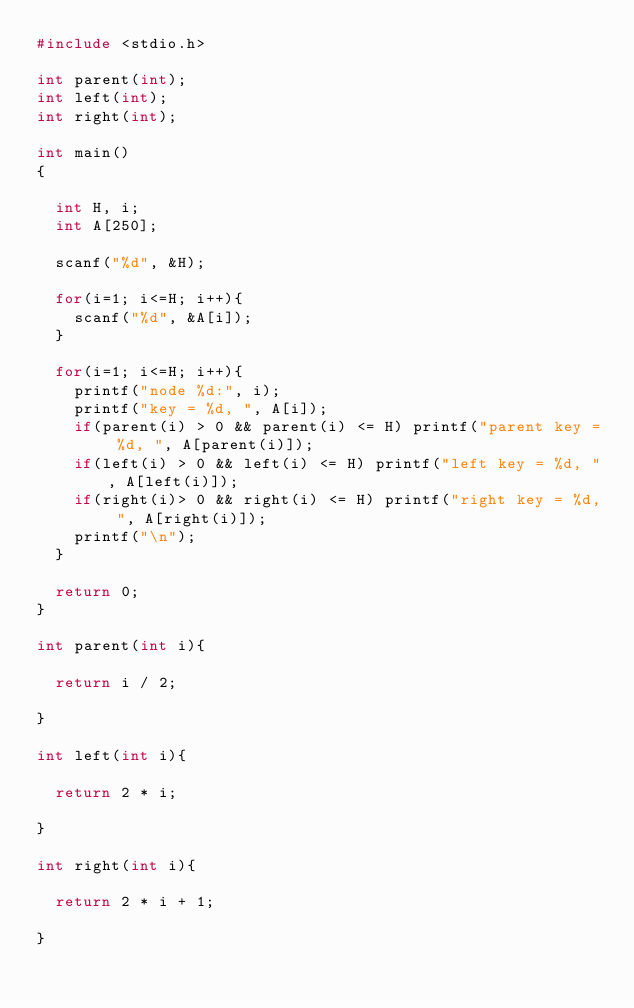<code> <loc_0><loc_0><loc_500><loc_500><_C_>#include <stdio.h>

int parent(int);
int left(int);
int right(int);

int main()
{

  int H, i;
  int A[250];

  scanf("%d", &H);

  for(i=1; i<=H; i++){
    scanf("%d", &A[i]);
  }

  for(i=1; i<=H; i++){
    printf("node %d:", i);
    printf("key = %d, ", A[i]);
    if(parent(i) > 0 && parent(i) <= H) printf("parent key = %d, ", A[parent(i)]);
    if(left(i) > 0 && left(i) <= H) printf("left key = %d, ", A[left(i)]);
    if(right(i)> 0 && right(i) <= H) printf("right key = %d, ", A[right(i)]);
    printf("\n");
  }

  return 0;
}

int parent(int i){

  return i / 2;

}

int left(int i){

  return 2 * i;

}

int right(int i){

  return 2 * i + 1;

}</code> 